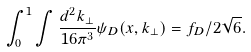Convert formula to latex. <formula><loc_0><loc_0><loc_500><loc_500>\int _ { 0 } ^ { 1 } \int { \frac { d ^ { 2 } k _ { \perp } } { 1 6 \pi ^ { 3 } } \psi _ { D } ( x , k _ { \perp } ) } = f _ { D } / 2 \sqrt { 6 } .</formula> 